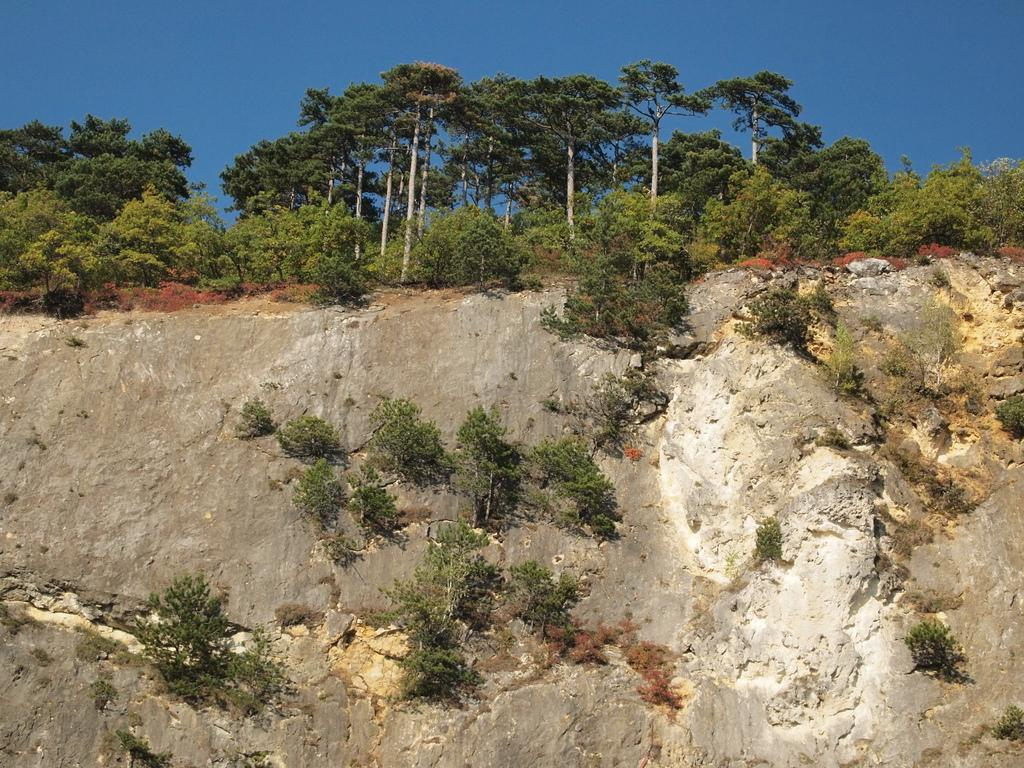What is visible in the center of the image? The sky, trees, plants, stones, and a few other objects are visible in the center of the image. Can you describe the natural elements present in the center of the image? Yes, there are trees and plants visible in the center of the image. What type of inanimate objects can be seen in the center of the image? Stones are visible in the center of the image. Can you see any tomatoes growing on the trees in the center of the image? There are no tomatoes visible in the image, as it features trees without any tomatoes. Is there a squirrel visible on any of the stones in the center of the image? There is no squirrel present in the image. 